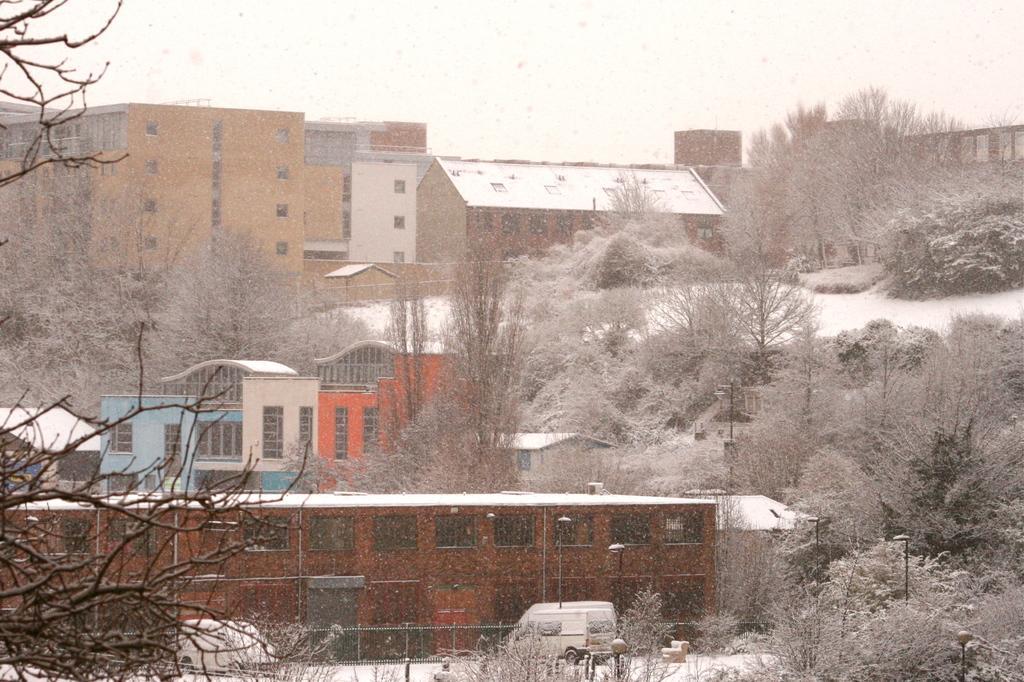Could you give a brief overview of what you see in this image? In this image we can see few buildings, there are some trees, windows, vehicles, poles and lights, also we can see the sky. 